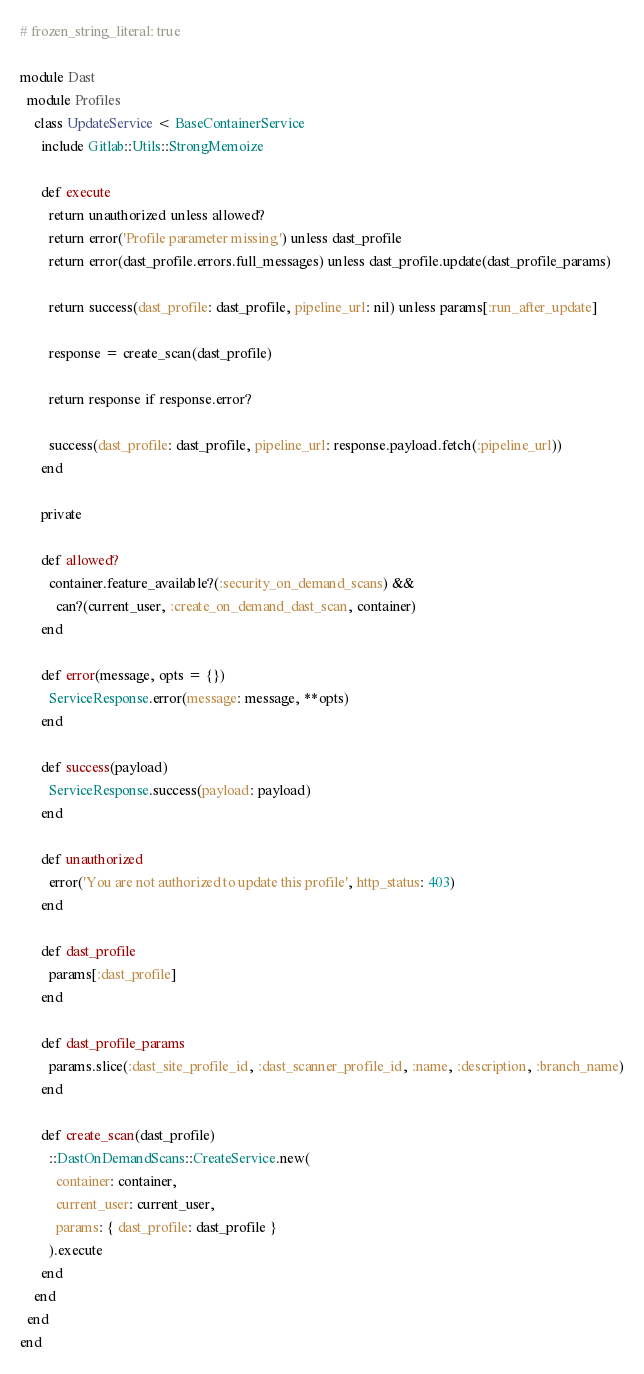Convert code to text. <code><loc_0><loc_0><loc_500><loc_500><_Ruby_># frozen_string_literal: true

module Dast
  module Profiles
    class UpdateService < BaseContainerService
      include Gitlab::Utils::StrongMemoize

      def execute
        return unauthorized unless allowed?
        return error('Profile parameter missing') unless dast_profile
        return error(dast_profile.errors.full_messages) unless dast_profile.update(dast_profile_params)

        return success(dast_profile: dast_profile, pipeline_url: nil) unless params[:run_after_update]

        response = create_scan(dast_profile)

        return response if response.error?

        success(dast_profile: dast_profile, pipeline_url: response.payload.fetch(:pipeline_url))
      end

      private

      def allowed?
        container.feature_available?(:security_on_demand_scans) &&
          can?(current_user, :create_on_demand_dast_scan, container)
      end

      def error(message, opts = {})
        ServiceResponse.error(message: message, **opts)
      end

      def success(payload)
        ServiceResponse.success(payload: payload)
      end

      def unauthorized
        error('You are not authorized to update this profile', http_status: 403)
      end

      def dast_profile
        params[:dast_profile]
      end

      def dast_profile_params
        params.slice(:dast_site_profile_id, :dast_scanner_profile_id, :name, :description, :branch_name)
      end

      def create_scan(dast_profile)
        ::DastOnDemandScans::CreateService.new(
          container: container,
          current_user: current_user,
          params: { dast_profile: dast_profile }
        ).execute
      end
    end
  end
end
</code> 